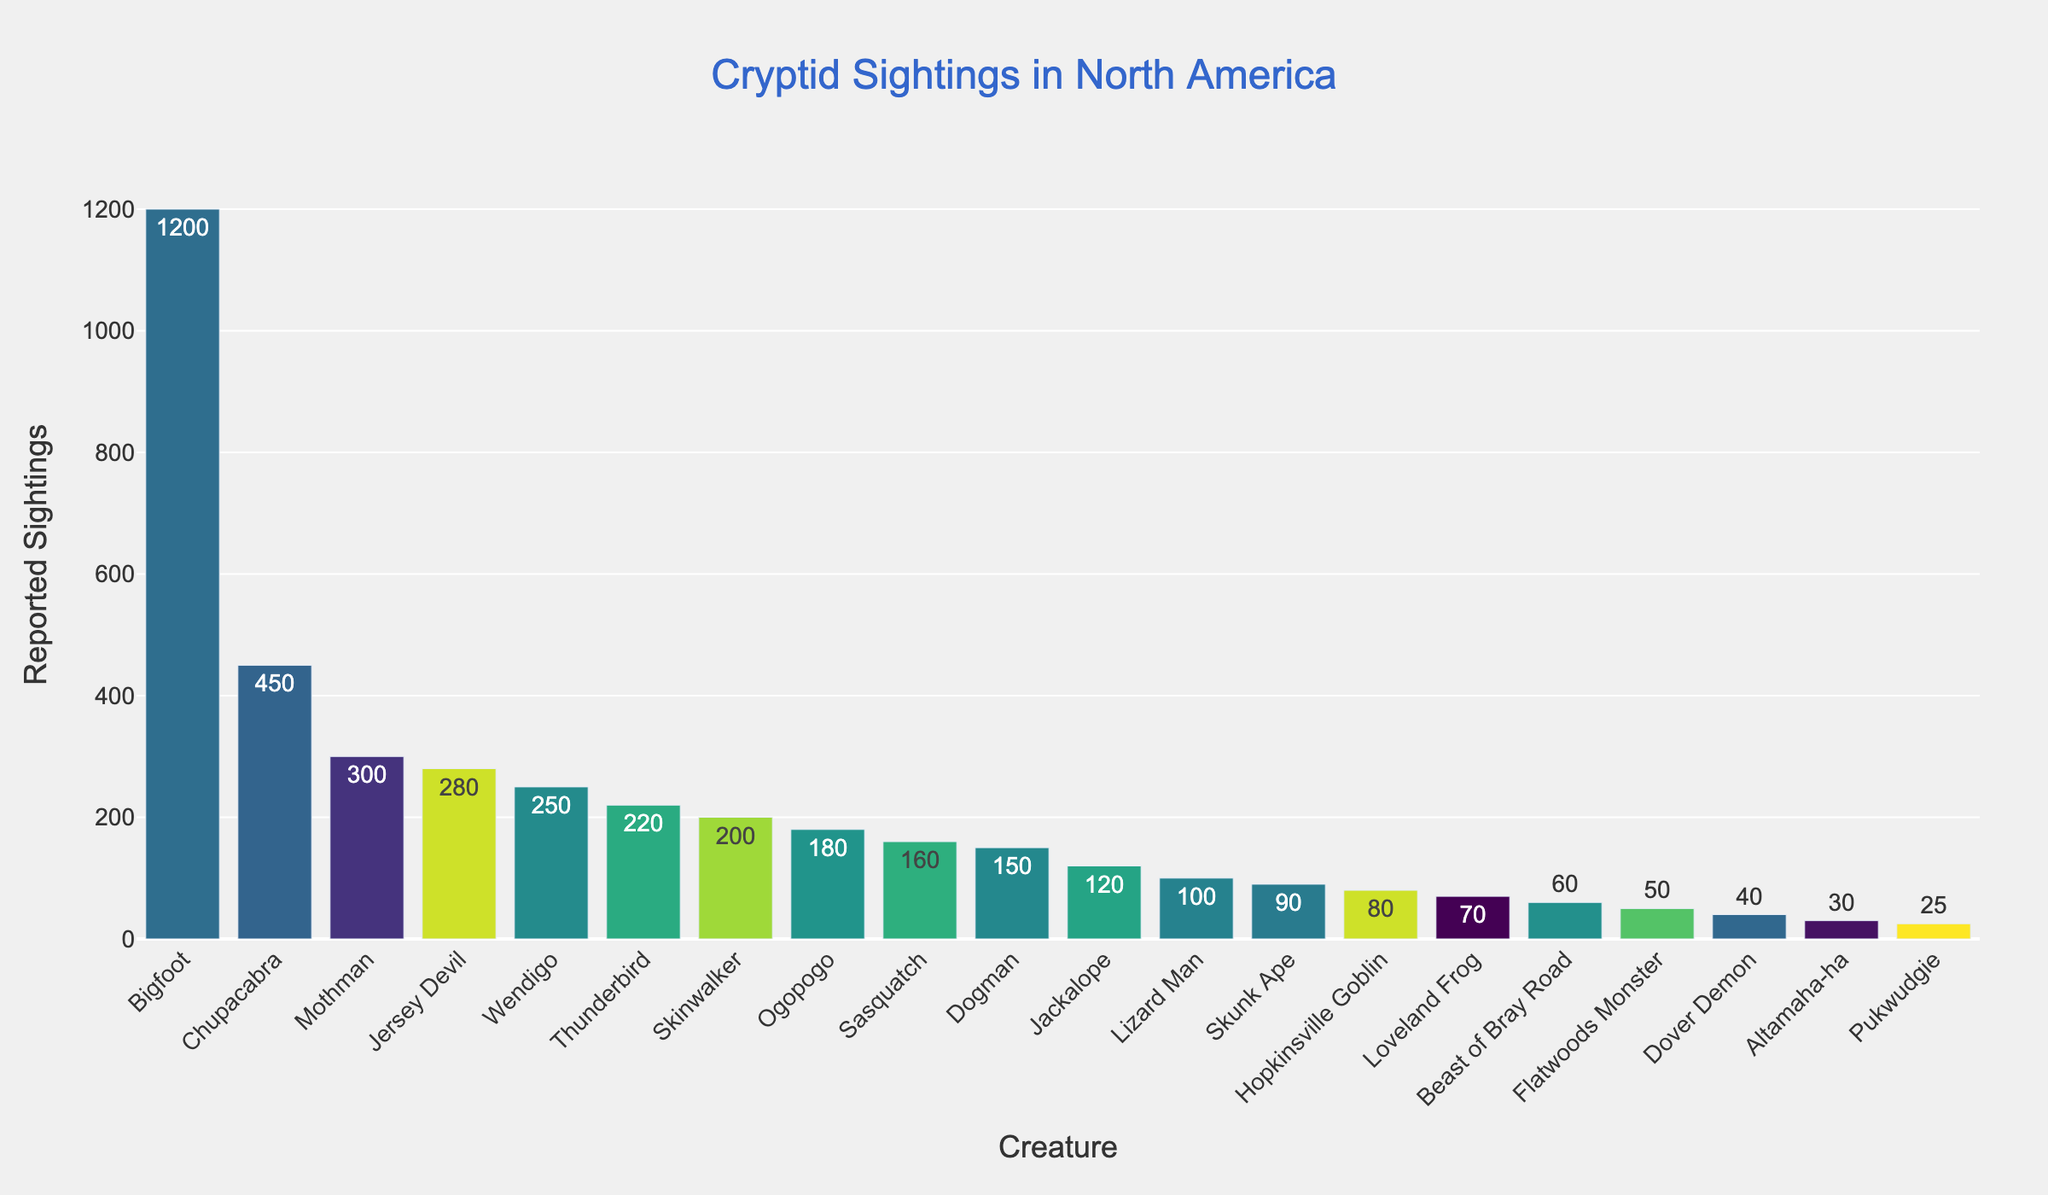Who has the highest number of reported sightings? Start by looking at the tallest bar in the chart, which has the highest value on the y-axis. The tallest bar represents Bigfoot, with a count of 1200 reported sightings.
Answer: Bigfoot What's the combined total of reported sightings for Skinwalker and Dogman? Add the reported sightings for Skinwalker (200) and Dogman (150) together: 200 + 150.
Answer: 350 Between Chupacabra and Mothman, which has more reported sightings? Compare the heights of the bars for Chupacabra (450) and Mothman (300). The bar for Chupacabra is taller than the bar for Mothman.
Answer: Chupacabra What is the difference in the number of reported sightings between Jersey Devil and Wendigo? Subtract the number of Wendigo sightings (250) from the number of Jersey Devil sightings (280): 280 - 250.
Answer: 30 What is the total number of reported sightings for creatures with more than 200 sightings? Add the reported sightings for creatures with more than 200 sightings: Bigfoot (1200) + Chupacabra (450) + Mothman (300) + Jersey Devil (280) + Wendigo (250) + Thunderbird (220). The total is 1200 + 450 + 300 + 280 + 250 + 220.
Answer: 2700 Which creature has exactly 100 reported sightings? Look for the bar that aligns with 100 on the y-axis. The creature represented by that bar is Lizard Man.
Answer: Lizard Man What is the average number of reported sightings for Bigfoot, Chupacabra, and Mothman? Add the reported sightings for Bigfoot (1200), Chupacabra (450), and Mothman (300), then divide by 3: (1200 + 450 + 300) / 3.
Answer: 650 How many creatures have fewer than 50 reported sightings? Count the bars that fall under the 50 mark on the y-axis. These creatures are Flatwoods Monster (50), Dover Demon (40), Altamaha-ha (30), and Pukwudgie (25).
Answer: 4 Which creature types fall between 90 and 180 reported sightings? Identify the bars whose y-axis values fall between 90 and 180. These creatures are Skunk Ape (90), Hopkinsville Goblin (80), Loveland Frog (70), Beast of Bray Road (60), and Jackalope (120).
Answer: Jackalope, Skunk Ape, Hopkinsville Goblin, Loveland Frog, Beast of Bray Road 